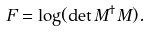<formula> <loc_0><loc_0><loc_500><loc_500>F = \log ( \det M ^ { \dag } M ) .</formula> 